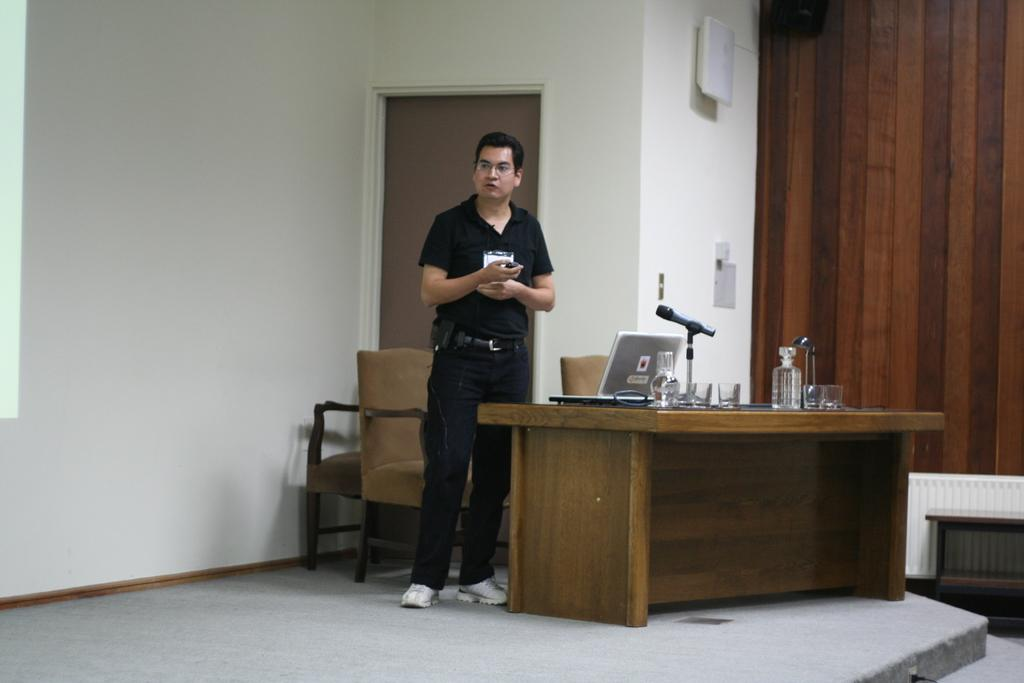What is the man in the image doing? There is no specific action mentioned for the man in the image, but he is standing. What objects are on the table in the image? There is a laptop, a microphone, and a bottle on the table in the image. What can be seen in the background of the image? There is a chair, a wall, and a paper in the background of the image. What type of jelly is being used to set off the alarm in the image? There is no mention of jelly or an alarm in the image. 